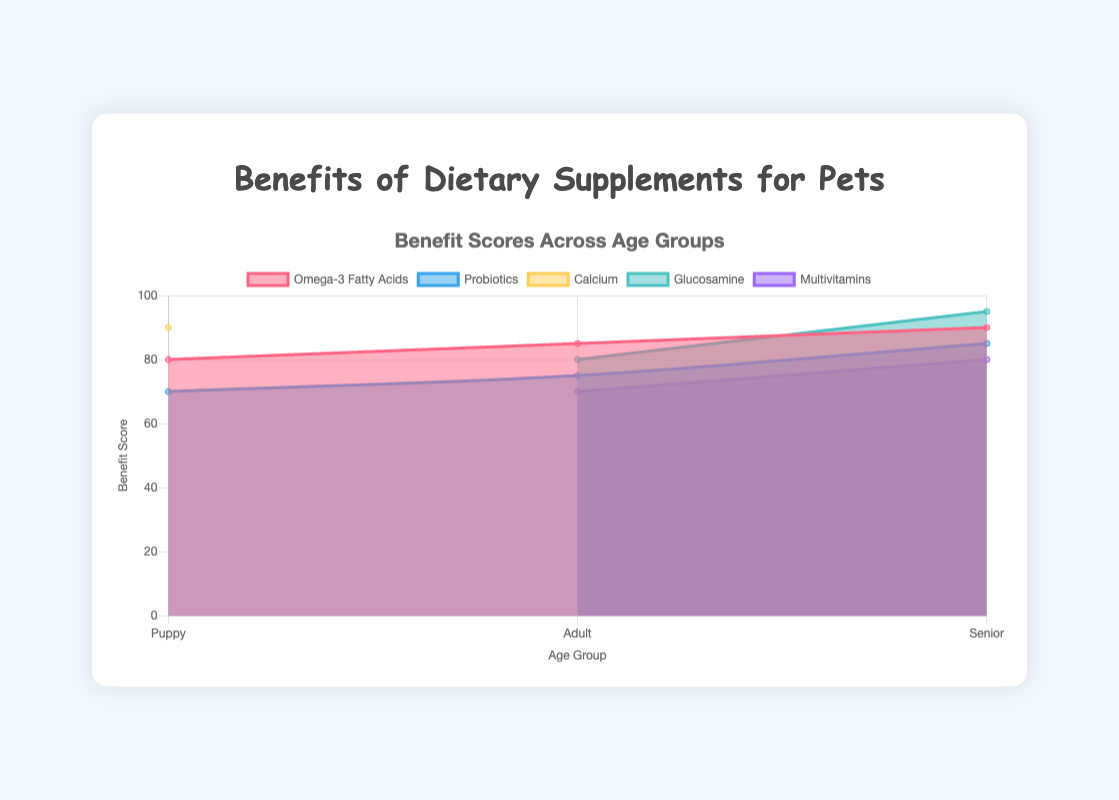What is the title of the figure? The title is displayed at the top of the figure, usually in a larger font size than other text, making it easy to identify. It states the main topic or focus of the chart.
Answer: Benefits of Dietary Supplements for Pets Which age group shows the highest benefit score for Probiotics? To find which age group has the highest benefit score for Probiotics, look at the segment of the chart corresponding to Probiotics for each age group and identify the highest score.
Answer: Senior What is the benefit score of Calcium for puppies? Locate the data series labeled 'Calcium' and read the value corresponding to the 'Puppy' age group on the x-axis.
Answer: 90 Does any supplement have a benefit score of 100 for any age group? Examine all the y-axis values across all datasets to check for any instance of the benefit score reaching 100.
Answer: No Compare the benefit scores of Omega-3 Fatty Acids for puppies and seniors. Which is higher? Locate the benefit scores of Omega-3 Fatty Acids for both age groups and compare. The benefit score for seniors (90) is higher than that for puppies (80).
Answer: Senior What is the average benefit score of Multivitamins across its available age groups? Multivitamins have scores for Adult (70) and Senior (80). Calculate the average by summing these scores and dividing by the number of age groups: (70 + 80) / 2 = 75.
Answer: 75 Which supplement shows a consistent increase in benefit scores from Puppy to Senior? Identify the supplement whose scores continually increase from Puppy to Adult to Senior. Omega-3 Fatty Acids increase consistently from 80 to 85 to 90.
Answer: Omega-3 Fatty Acids How many supplements are shown in the figure? Count the number of distinct labels or datasets in the figure’s legend.
Answer: 5 What is the difference in benefit scores of Glucosamine between adults and seniors? Locate the scores for Glucosamine for adults (80) and seniors (95), then subtract the adult score from the senior score: 95 - 80 = 15.
Answer: 15 